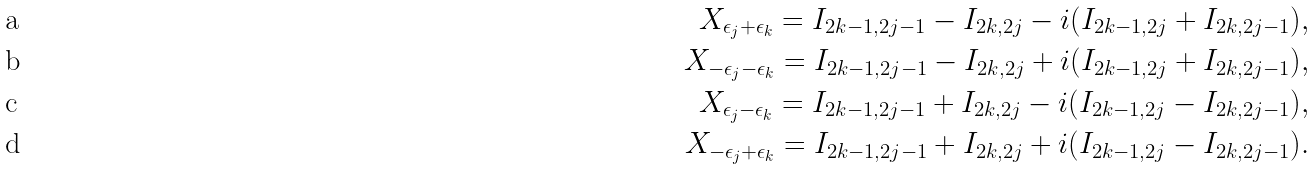<formula> <loc_0><loc_0><loc_500><loc_500>X _ { \epsilon _ { j } + \epsilon _ { k } } = I _ { 2 k - 1 , 2 j - 1 } - I _ { 2 k , 2 j } - i ( I _ { 2 k - 1 , 2 j } + I _ { 2 k , 2 j - 1 } ) , \\ X _ { - \epsilon _ { j } - \epsilon _ { k } } = I _ { 2 k - 1 , 2 j - 1 } - I _ { 2 k , 2 j } + i ( I _ { 2 k - 1 , 2 j } + I _ { 2 k , 2 j - 1 } ) , \\ X _ { \epsilon _ { j } - \epsilon _ { k } } = I _ { 2 k - 1 , 2 j - 1 } + I _ { 2 k , 2 j } - i ( I _ { 2 k - 1 , 2 j } - I _ { 2 k , 2 j - 1 } ) , \\ X _ { - \epsilon _ { j } + \epsilon _ { k } } = I _ { 2 k - 1 , 2 j - 1 } + I _ { 2 k , 2 j } + i ( I _ { 2 k - 1 , 2 j } - I _ { 2 k , 2 j - 1 } ) .</formula> 